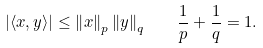<formula> <loc_0><loc_0><loc_500><loc_500>\left | \langle x , y \rangle \right | \leq \left \| x \right \| _ { p } \left \| y \right \| _ { q } \quad { \frac { 1 } { p } } + { \frac { 1 } { q } } = 1 .</formula> 